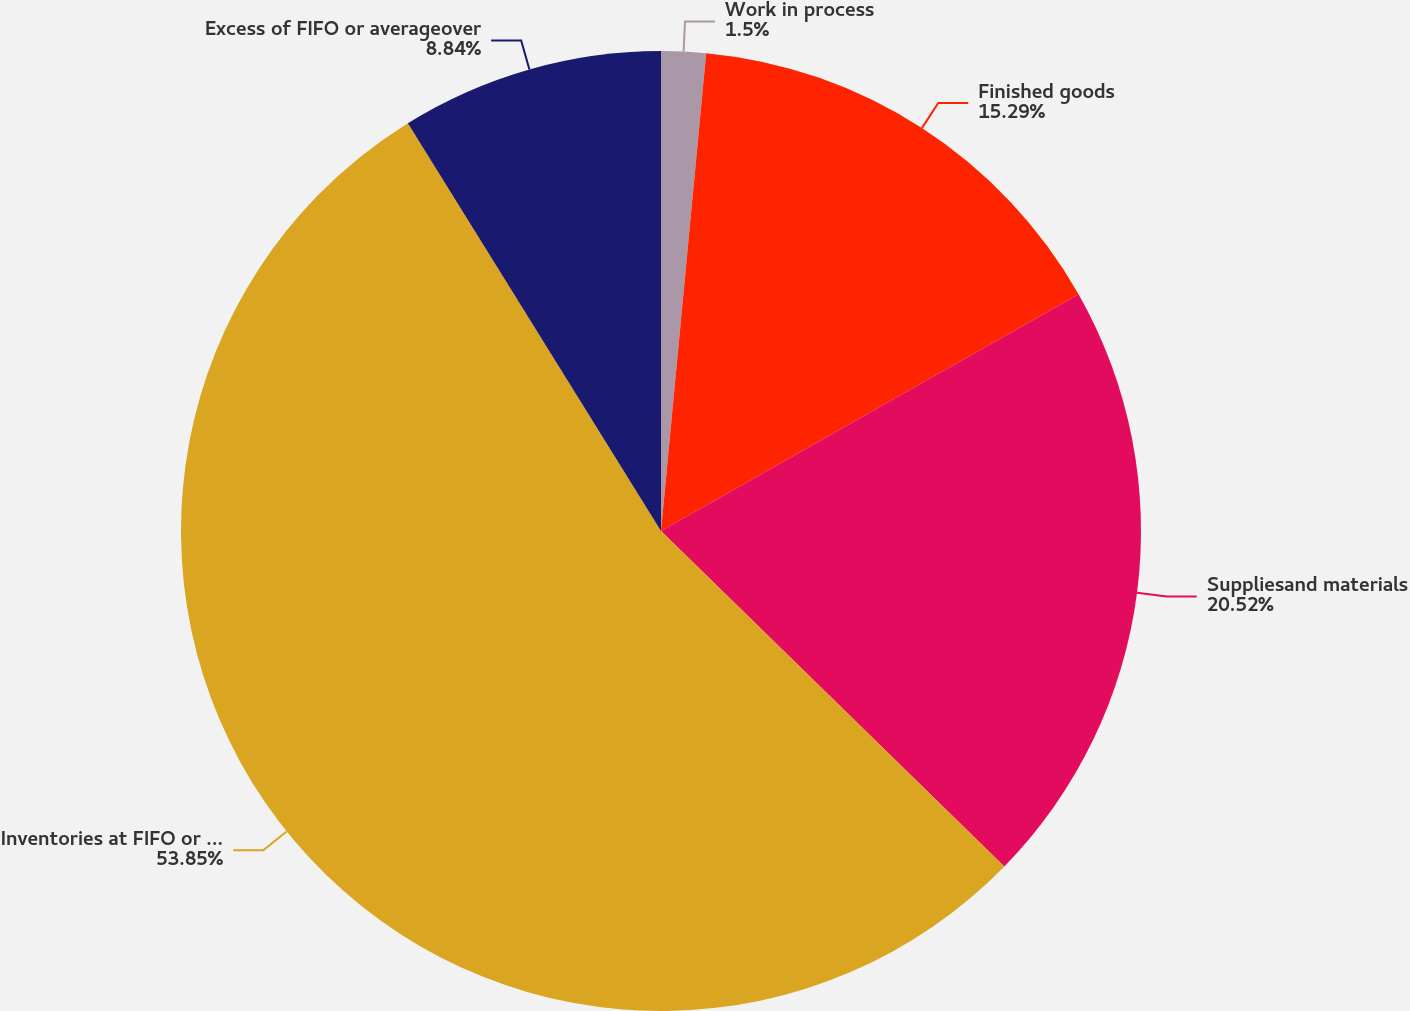Convert chart. <chart><loc_0><loc_0><loc_500><loc_500><pie_chart><fcel>Work in process<fcel>Finished goods<fcel>Suppliesand materials<fcel>Inventories at FIFO or average<fcel>Excess of FIFO or averageover<nl><fcel>1.5%<fcel>15.29%<fcel>20.52%<fcel>53.84%<fcel>8.84%<nl></chart> 